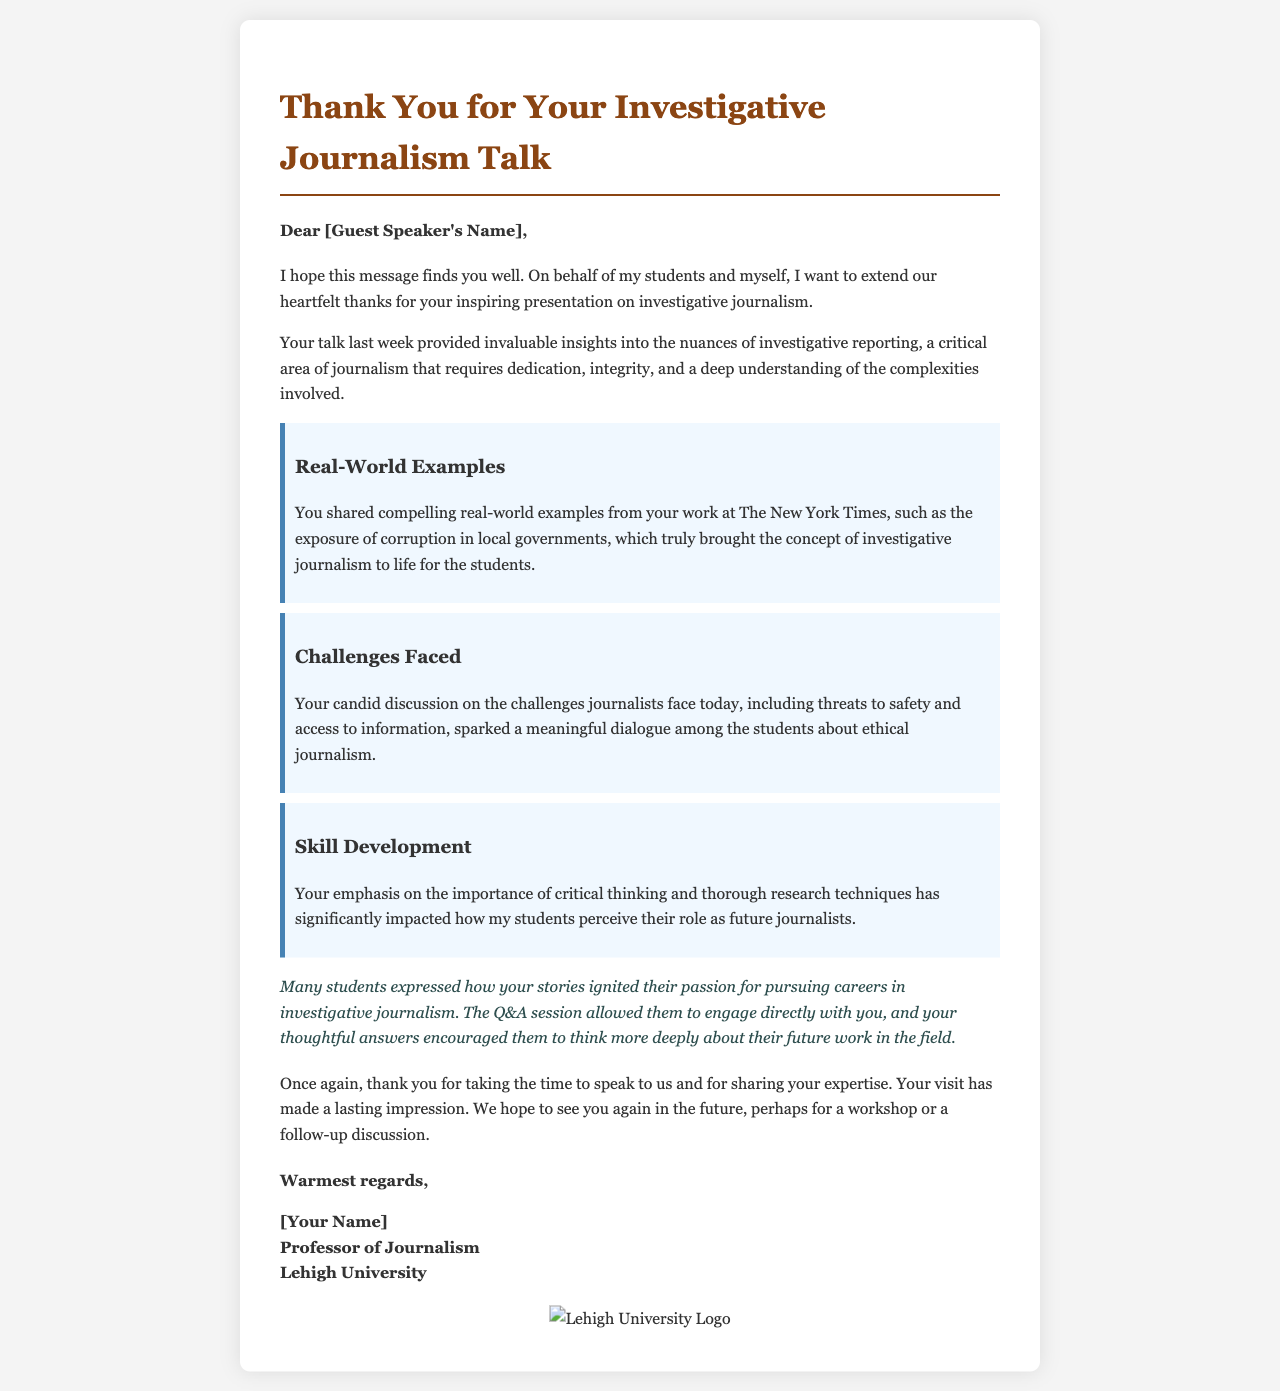What is the title of the letter? The title of the letter is indicated by the heading at the top of the document.
Answer: Thank You for Your Investigative Journalism Talk Who is the letter addressed to? The letter starts with a greeting that includes the name of the recipient.
Answer: [Guest Speaker's Name] What key topic did the speaker discuss regarding investigative journalism? The document lists several key topics emphasized by the speaker during the talk.
Answer: Investigative reporting Name one real-world example shared by the speaker. The letter mentions specific examples used to illustrate aspects of investigative journalism.
Answer: Exposure of corruption in local governments What was highlighted as a challenge faced by journalists today? The letter references specific challenges that were discussed during the talk.
Answer: Threats to safety and access to information Which university is represented in the letter? The signature block at the end of the letter indicates the affiliation of the sender.
Answer: Lehigh University What impact did the talk have on the students? The letter reflects on the influence the speaker's discussion had on the students' perceptions and aspirations.
Answer: Ignited their passion What is the purpose of this letter? The document's overall structure and content demonstrate its main intent.
Answer: To express gratitude for the guest speaker's presentation What kind of session followed the presentation? The letter indicates activities that took place after the main talk.
Answer: Q&A session 